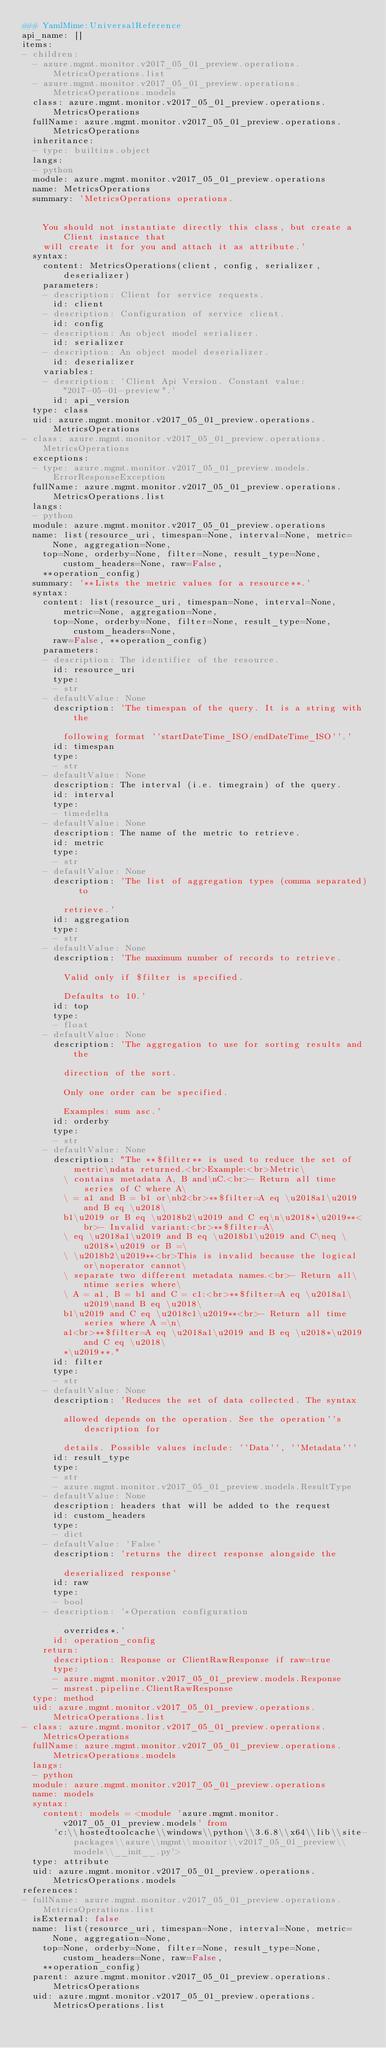<code> <loc_0><loc_0><loc_500><loc_500><_YAML_>### YamlMime:UniversalReference
api_name: []
items:
- children:
  - azure.mgmt.monitor.v2017_05_01_preview.operations.MetricsOperations.list
  - azure.mgmt.monitor.v2017_05_01_preview.operations.MetricsOperations.models
  class: azure.mgmt.monitor.v2017_05_01_preview.operations.MetricsOperations
  fullName: azure.mgmt.monitor.v2017_05_01_preview.operations.MetricsOperations
  inheritance:
  - type: builtins.object
  langs:
  - python
  module: azure.mgmt.monitor.v2017_05_01_preview.operations
  name: MetricsOperations
  summary: 'MetricsOperations operations.


    You should not instantiate directly this class, but create a Client instance that
    will create it for you and attach it as attribute.'
  syntax:
    content: MetricsOperations(client, config, serializer, deserializer)
    parameters:
    - description: Client for service requests.
      id: client
    - description: Configuration of service client.
      id: config
    - description: An object model serializer.
      id: serializer
    - description: An object model deserializer.
      id: deserializer
    variables:
    - description: 'Client Api Version. Constant value: "2017-05-01-preview".'
      id: api_version
  type: class
  uid: azure.mgmt.monitor.v2017_05_01_preview.operations.MetricsOperations
- class: azure.mgmt.monitor.v2017_05_01_preview.operations.MetricsOperations
  exceptions:
  - type: azure.mgmt.monitor.v2017_05_01_preview.models.ErrorResponseException
  fullName: azure.mgmt.monitor.v2017_05_01_preview.operations.MetricsOperations.list
  langs:
  - python
  module: azure.mgmt.monitor.v2017_05_01_preview.operations
  name: list(resource_uri, timespan=None, interval=None, metric=None, aggregation=None,
    top=None, orderby=None, filter=None, result_type=None, custom_headers=None, raw=False,
    **operation_config)
  summary: '**Lists the metric values for a resource**.'
  syntax:
    content: list(resource_uri, timespan=None, interval=None, metric=None, aggregation=None,
      top=None, orderby=None, filter=None, result_type=None, custom_headers=None,
      raw=False, **operation_config)
    parameters:
    - description: The identifier of the resource.
      id: resource_uri
      type:
      - str
    - defaultValue: None
      description: 'The timespan of the query. It is a string with the

        following format ''startDateTime_ISO/endDateTime_ISO''.'
      id: timespan
      type:
      - str
    - defaultValue: None
      description: The interval (i.e. timegrain) of the query.
      id: interval
      type:
      - timedelta
    - defaultValue: None
      description: The name of the metric to retrieve.
      id: metric
      type:
      - str
    - defaultValue: None
      description: 'The list of aggregation types (comma separated) to

        retrieve.'
      id: aggregation
      type:
      - str
    - defaultValue: None
      description: 'The maximum number of records to retrieve.

        Valid only if $filter is specified.

        Defaults to 10.'
      id: top
      type:
      - float
    - defaultValue: None
      description: 'The aggregation to use for sorting results and the

        direction of the sort.

        Only one order can be specified.

        Examples: sum asc.'
      id: orderby
      type:
      - str
    - defaultValue: None
      description: "The **$filter** is used to reduce the set of metric\ndata returned.<br>Example:<br>Metric\
        \ contains metadata A, B and\nC.<br>- Return all time series of C where A\
        \ = a1 and B = b1 or\nb2<br>**$filter=A eq \u2018a1\u2019 and B eq \u2018\
        b1\u2019 or B eq \u2018b2\u2019 and C eq\n\u2018*\u2019**<br>- Invalid variant:<br>**$filter=A\
        \ eq \u2018a1\u2019 and B eq \u2018b1\u2019 and C\neq \u2018*\u2019 or B =\
        \ \u2018b2\u2019**<br>This is invalid because the logical or\noperator cannot\
        \ separate two different metadata names.<br>- Return all\ntime series where\
        \ A = a1, B = b1 and C = c1:<br>**$filter=A eq \u2018a1\u2019\nand B eq \u2018\
        b1\u2019 and C eq \u2018c1\u2019**<br>- Return all time series where A =\n\
        a1<br>**$filter=A eq \u2018a1\u2019 and B eq \u2018*\u2019 and C eq \u2018\
        *\u2019**."
      id: filter
      type:
      - str
    - defaultValue: None
      description: 'Reduces the set of data collected. The syntax

        allowed depends on the operation. See the operation''s description for

        details. Possible values include: ''Data'', ''Metadata'''
      id: result_type
      type:
      - str
      - azure.mgmt.monitor.v2017_05_01_preview.models.ResultType
    - defaultValue: None
      description: headers that will be added to the request
      id: custom_headers
      type:
      - dict
    - defaultValue: 'False'
      description: 'returns the direct response alongside the

        deserialized response'
      id: raw
      type:
      - bool
    - description: '*Operation configuration

        overrides*.'
      id: operation_config
    return:
      description: Response or ClientRawResponse if raw=true
      type:
      - azure.mgmt.monitor.v2017_05_01_preview.models.Response
      - msrest.pipeline.ClientRawResponse
  type: method
  uid: azure.mgmt.monitor.v2017_05_01_preview.operations.MetricsOperations.list
- class: azure.mgmt.monitor.v2017_05_01_preview.operations.MetricsOperations
  fullName: azure.mgmt.monitor.v2017_05_01_preview.operations.MetricsOperations.models
  langs:
  - python
  module: azure.mgmt.monitor.v2017_05_01_preview.operations
  name: models
  syntax:
    content: models = <module 'azure.mgmt.monitor.v2017_05_01_preview.models' from
      'c:\\hostedtoolcache\\windows\\python\\3.6.8\\x64\\lib\\site-packages\\azure\\mgmt\\monitor\\v2017_05_01_preview\\models\\__init__.py'>
  type: attribute
  uid: azure.mgmt.monitor.v2017_05_01_preview.operations.MetricsOperations.models
references:
- fullName: azure.mgmt.monitor.v2017_05_01_preview.operations.MetricsOperations.list
  isExternal: false
  name: list(resource_uri, timespan=None, interval=None, metric=None, aggregation=None,
    top=None, orderby=None, filter=None, result_type=None, custom_headers=None, raw=False,
    **operation_config)
  parent: azure.mgmt.monitor.v2017_05_01_preview.operations.MetricsOperations
  uid: azure.mgmt.monitor.v2017_05_01_preview.operations.MetricsOperations.list</code> 